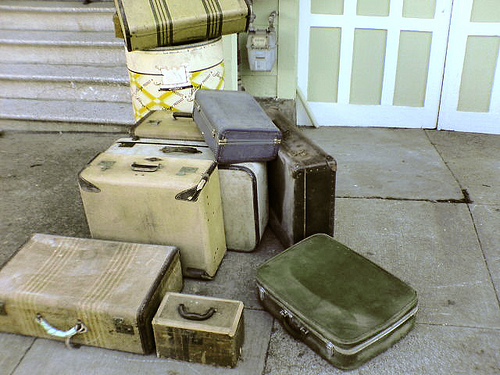<image>What appliance is abandoned here? There is no appliance abandoned here. It seems there is a confusion with luggage or suitcase. What appliance is abandoned here? It is not clear what appliance is abandoned here. It can be seen suitcases, luggage, or a washer. 